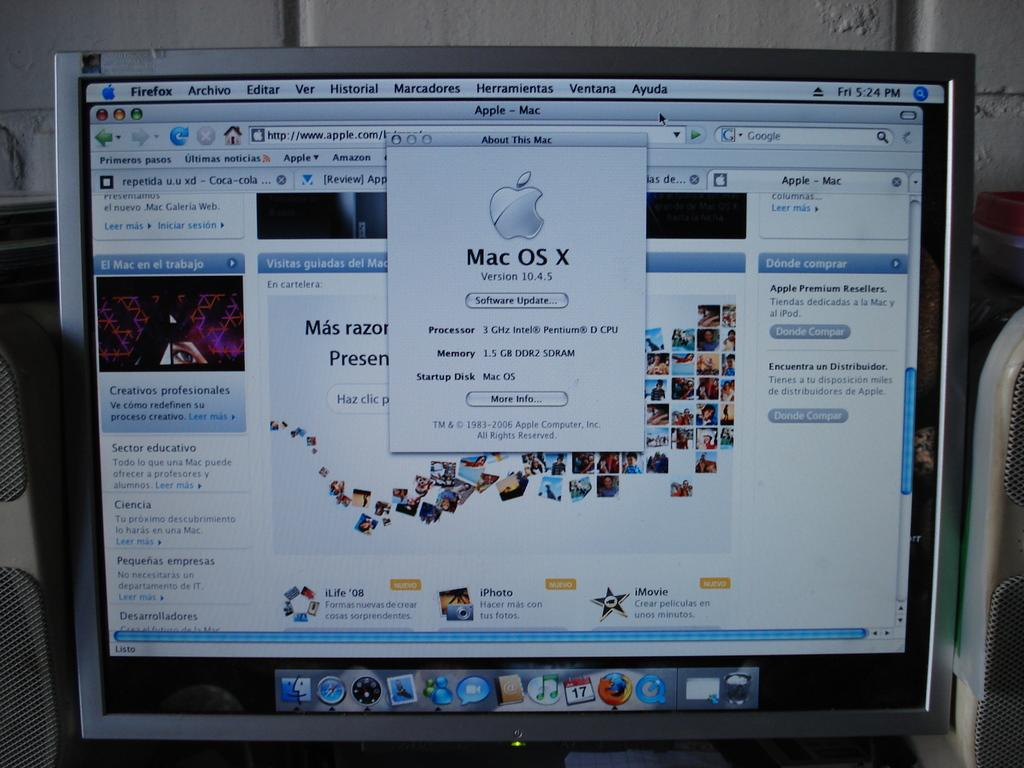<image>
Summarize the visual content of the image. A computer which is using the Mac OS X operating system. 